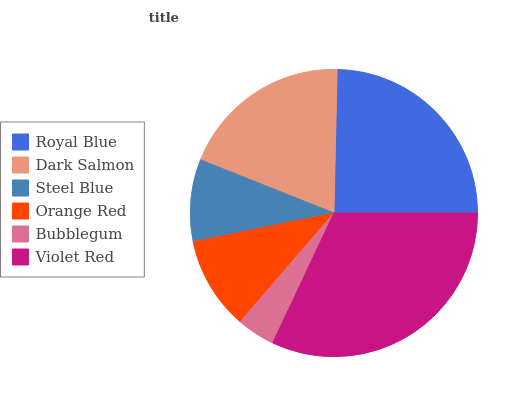Is Bubblegum the minimum?
Answer yes or no. Yes. Is Violet Red the maximum?
Answer yes or no. Yes. Is Dark Salmon the minimum?
Answer yes or no. No. Is Dark Salmon the maximum?
Answer yes or no. No. Is Royal Blue greater than Dark Salmon?
Answer yes or no. Yes. Is Dark Salmon less than Royal Blue?
Answer yes or no. Yes. Is Dark Salmon greater than Royal Blue?
Answer yes or no. No. Is Royal Blue less than Dark Salmon?
Answer yes or no. No. Is Dark Salmon the high median?
Answer yes or no. Yes. Is Orange Red the low median?
Answer yes or no. Yes. Is Bubblegum the high median?
Answer yes or no. No. Is Dark Salmon the low median?
Answer yes or no. No. 